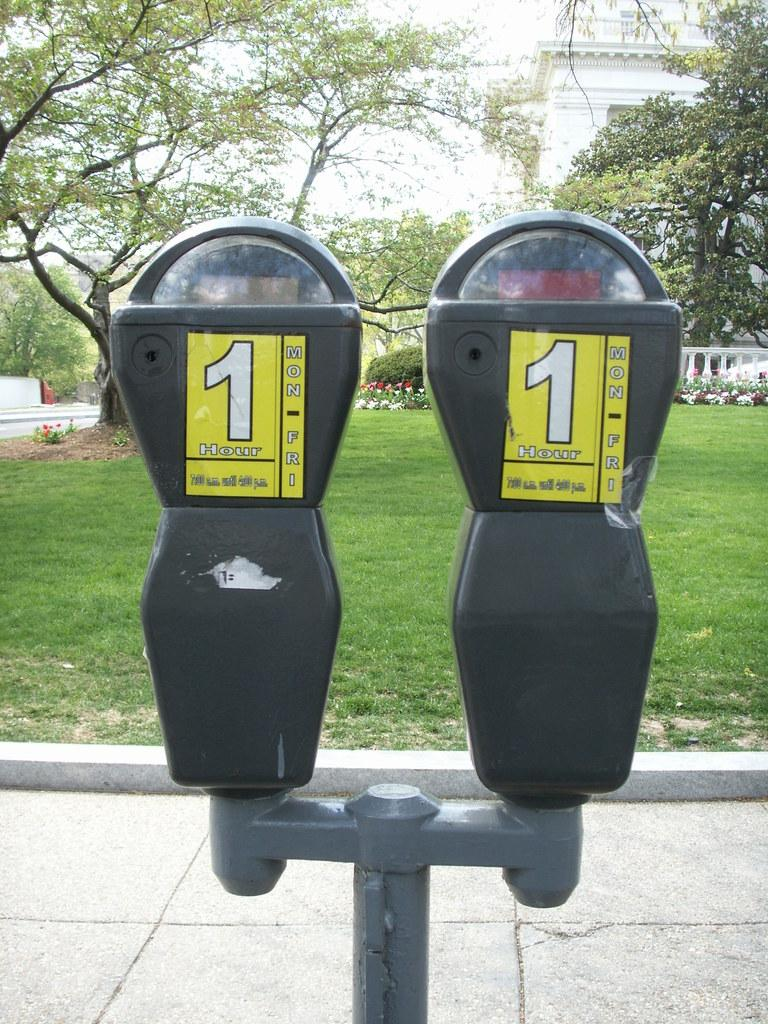What type of structure can be seen in the image? There is a building in the image. What natural elements are present in the image? There are trees and grass in the image. What object can be found on the sidewalk? There is a parking machine on the sidewalk. What type of vase can be seen on the roof of the building? There is no vase present on the roof of the building in the image. 